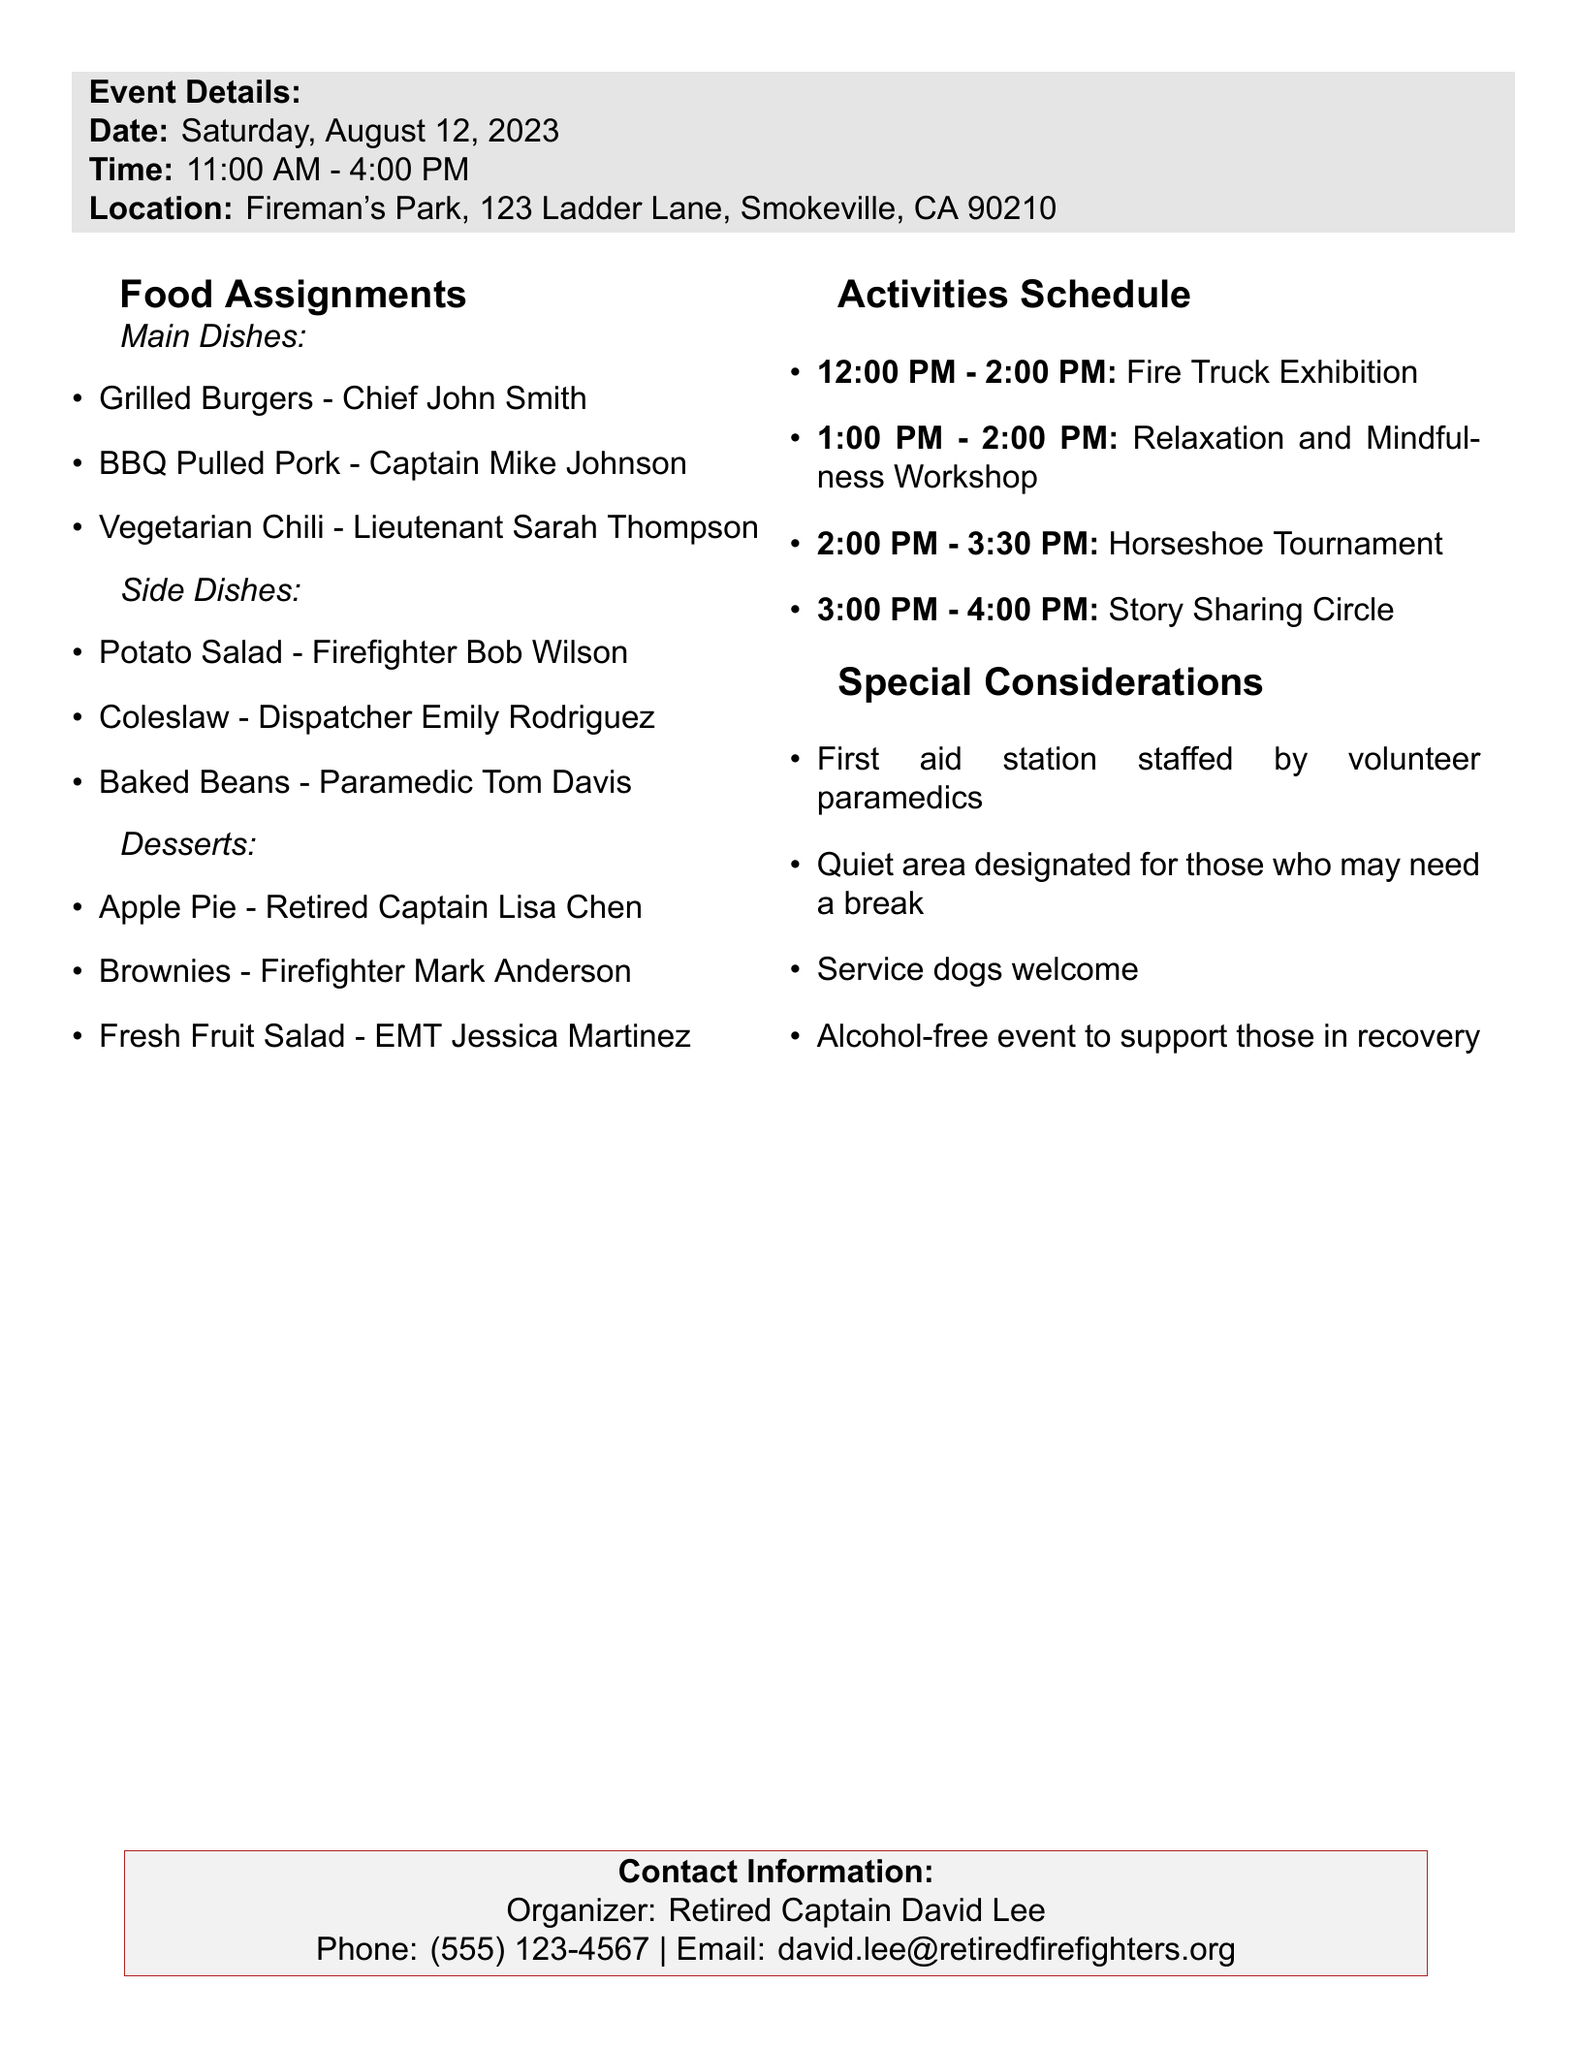What is the date of the annual picnic? The date is explicitly stated in the event details of the document.
Answer: Saturday, August 12, 2023 Who is responsible for the Vegetarian Chili? The food assignments list who is responsible for each dish in the main dishes category.
Answer: Lieutenant Sarah Thompson What time does the Horseshoe Tournament start? The activities schedule outlines the time for each event, including the Horseshoe Tournament.
Answer: 2:00 PM What should participants do if they need a break from stimulation? The document includes information about special considerations for participant comfort.
Answer: Quiet area designated for those who may need a break Who is the organizer of the event? The contact information section provides the name of the person organizing the picnic.
Answer: Retired Captain David Lee How long does the Relaxation and Mindfulness Workshop last? The activities schedule indicates the duration of each activity.
Answer: 1 hour What type of event is the Fire Truck Exhibition? The description provides a brief overview of the nature of the exhibition.
Answer: Display of vintage and modern fire trucks Is the event alcohol-free? Special considerations clearly state the rules regarding alcohol at the event.
Answer: Yes 